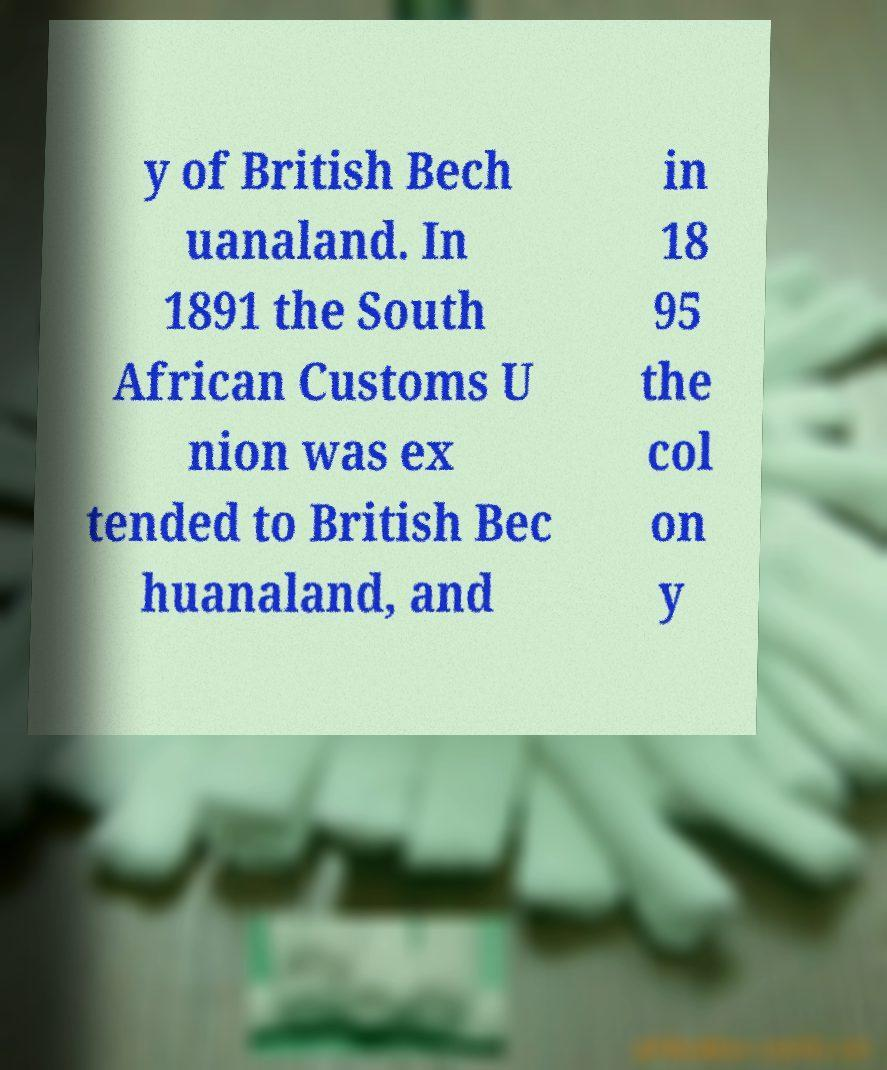Please identify and transcribe the text found in this image. y of British Bech uanaland. In 1891 the South African Customs U nion was ex tended to British Bec huanaland, and in 18 95 the col on y 